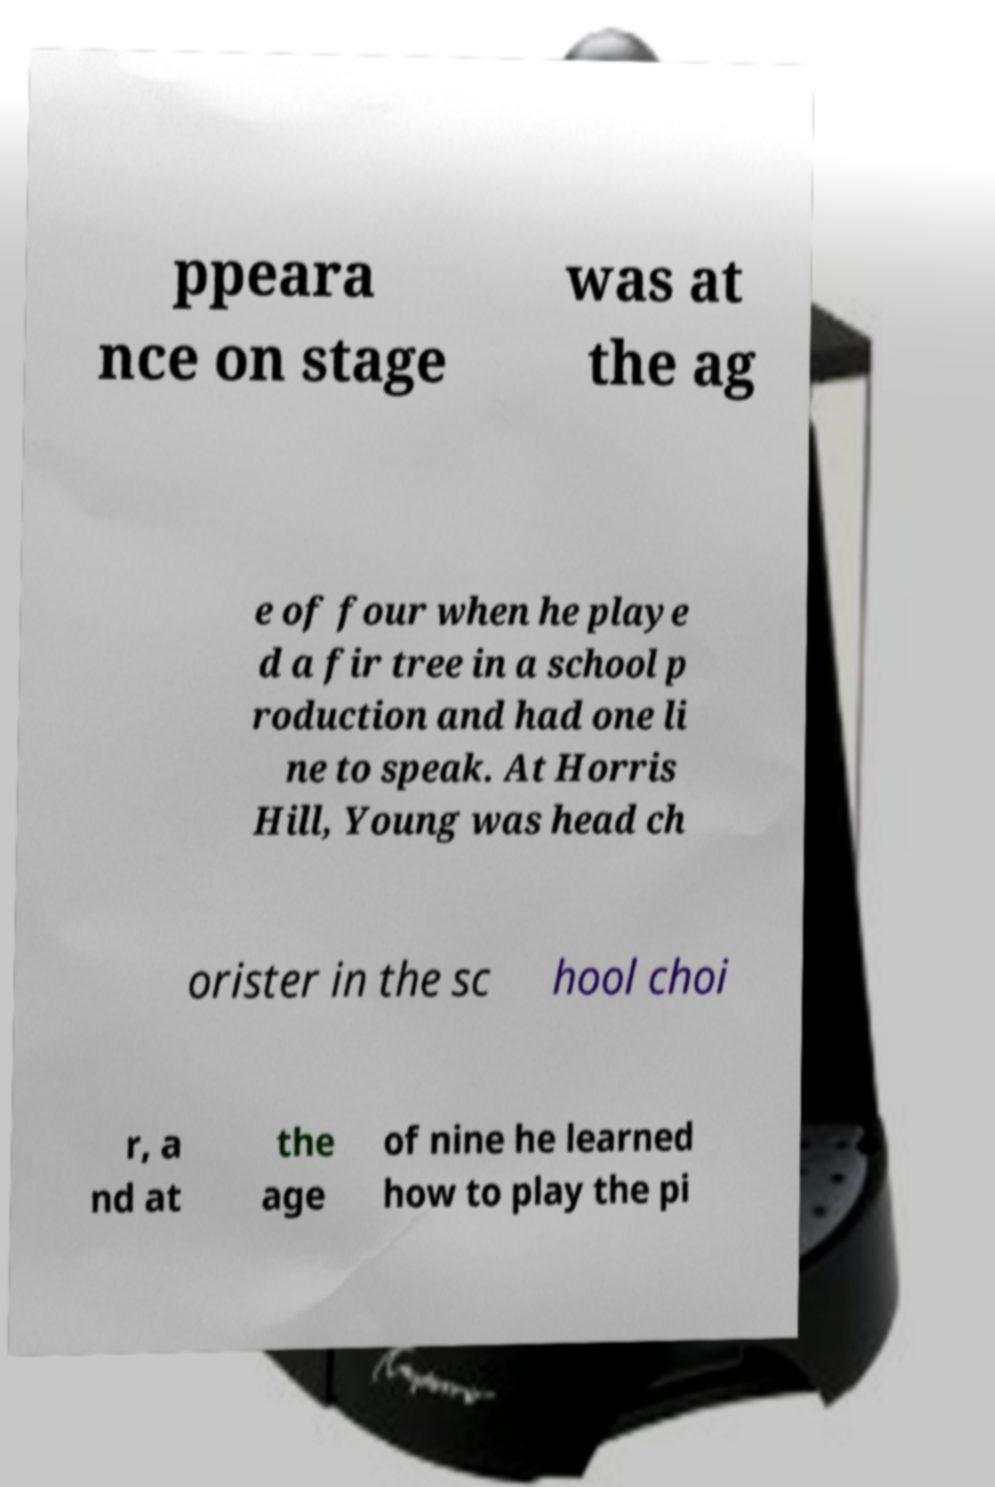For documentation purposes, I need the text within this image transcribed. Could you provide that? ppeara nce on stage was at the ag e of four when he playe d a fir tree in a school p roduction and had one li ne to speak. At Horris Hill, Young was head ch orister in the sc hool choi r, a nd at the age of nine he learned how to play the pi 